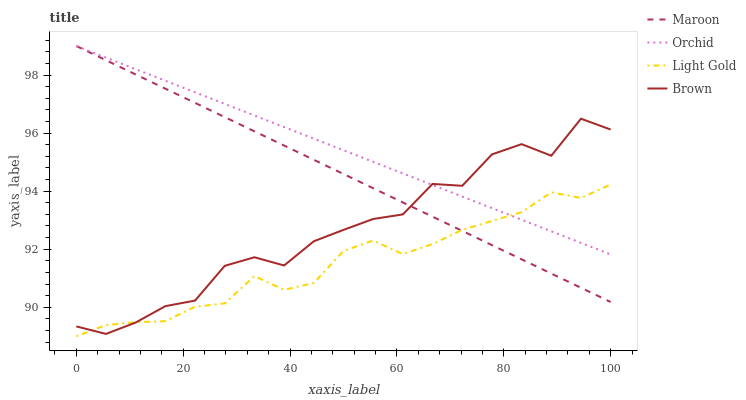Does Light Gold have the minimum area under the curve?
Answer yes or no. Yes. Does Orchid have the maximum area under the curve?
Answer yes or no. Yes. Does Maroon have the minimum area under the curve?
Answer yes or no. No. Does Maroon have the maximum area under the curve?
Answer yes or no. No. Is Orchid the smoothest?
Answer yes or no. Yes. Is Brown the roughest?
Answer yes or no. Yes. Is Light Gold the smoothest?
Answer yes or no. No. Is Light Gold the roughest?
Answer yes or no. No. Does Light Gold have the lowest value?
Answer yes or no. Yes. Does Maroon have the lowest value?
Answer yes or no. No. Does Orchid have the highest value?
Answer yes or no. Yes. Does Light Gold have the highest value?
Answer yes or no. No. Does Brown intersect Light Gold?
Answer yes or no. Yes. Is Brown less than Light Gold?
Answer yes or no. No. Is Brown greater than Light Gold?
Answer yes or no. No. 